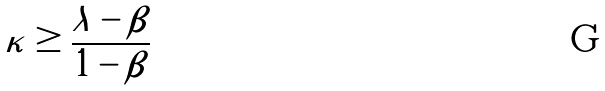<formula> <loc_0><loc_0><loc_500><loc_500>\kappa \geq \frac { \lambda - \beta } { 1 - \beta }</formula> 